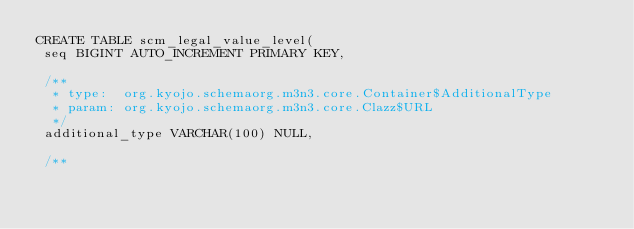Convert code to text. <code><loc_0><loc_0><loc_500><loc_500><_SQL_>CREATE TABLE scm_legal_value_level(
 seq BIGINT AUTO_INCREMENT PRIMARY KEY,

 /**
  * type:  org.kyojo.schemaorg.m3n3.core.Container$AdditionalType
  * param: org.kyojo.schemaorg.m3n3.core.Clazz$URL
  */
 additional_type VARCHAR(100) NULL,

 /**</code> 